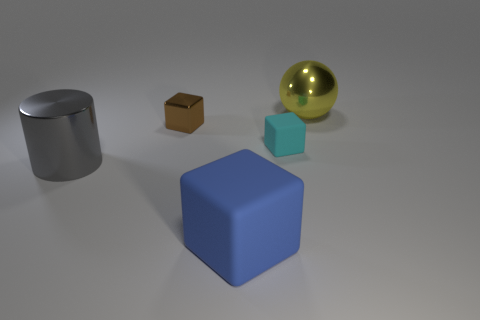What is the material of the cube in front of the matte thing that is behind the big metal thing that is on the left side of the large yellow sphere?
Your answer should be very brief. Rubber. What color is the ball that is made of the same material as the gray object?
Provide a succinct answer. Yellow. What number of large gray objects are in front of the large object behind the tiny thing that is on the right side of the tiny brown block?
Offer a terse response. 1. Is there any other thing that is the same shape as the large gray object?
Offer a very short reply. No. What number of things are either large objects to the right of the large gray metallic cylinder or yellow cylinders?
Keep it short and to the point. 2. There is a large object to the right of the rubber block behind the blue cube; what shape is it?
Provide a succinct answer. Sphere. Is the number of large cubes that are behind the big gray metallic cylinder less than the number of objects that are in front of the large ball?
Give a very brief answer. Yes. There is a blue thing that is the same shape as the small brown object; what size is it?
Keep it short and to the point. Large. What number of objects are either big things that are left of the large shiny sphere or blocks that are to the right of the brown metal block?
Ensure brevity in your answer.  3. Is the brown metallic cube the same size as the blue object?
Provide a succinct answer. No. 